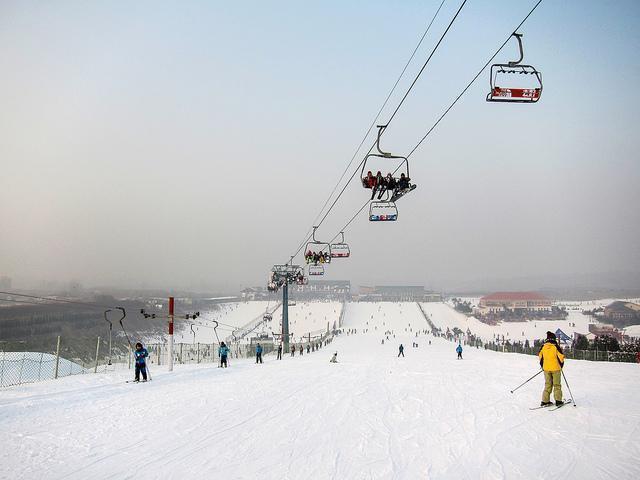What would happen if you cut the top wires?
Indicate the correct choice and explain in the format: 'Answer: answer
Rationale: rationale.'
Options: Nothing, can't call, laundry falls, people injured. Answer: people injured.
Rationale: People would fall off the trams. 